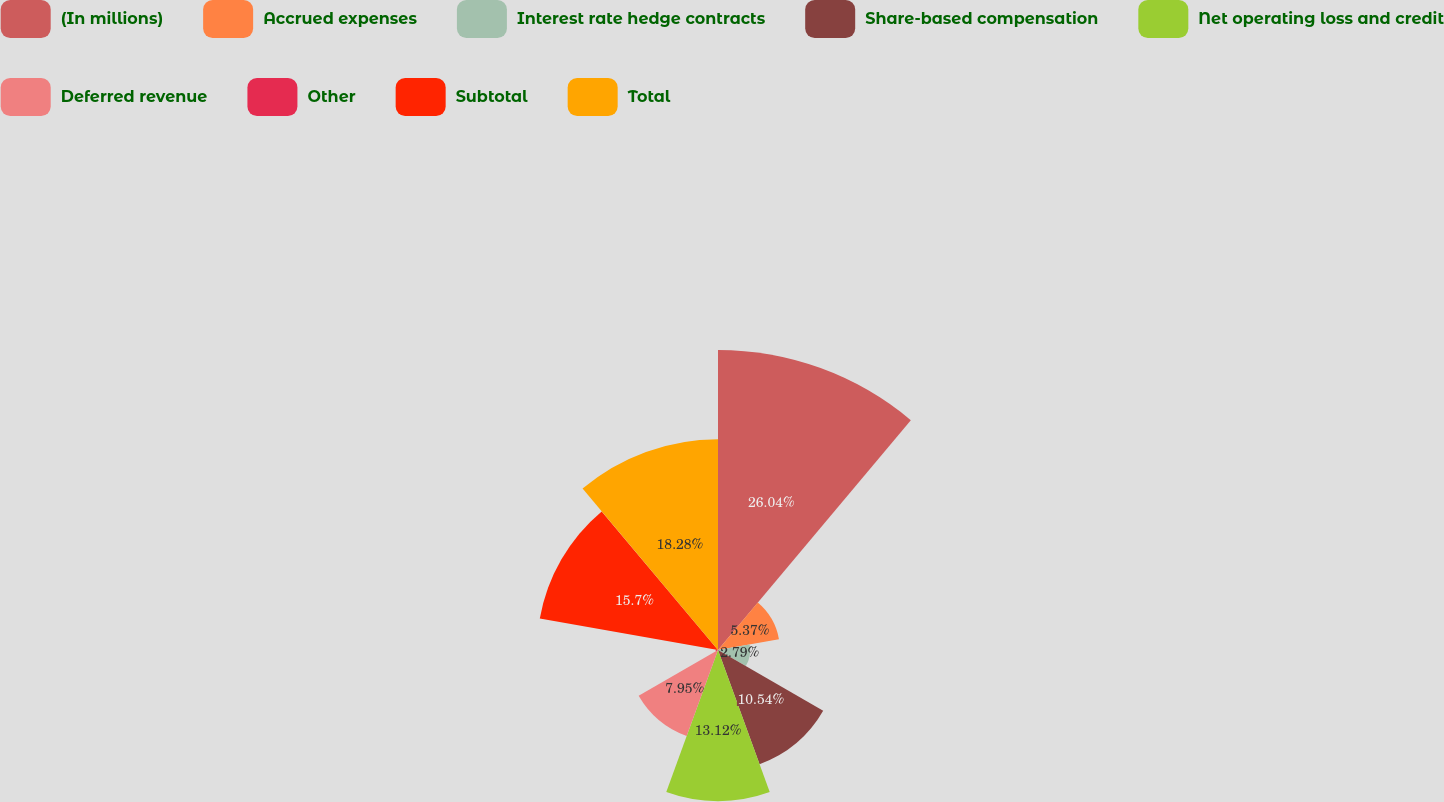Convert chart. <chart><loc_0><loc_0><loc_500><loc_500><pie_chart><fcel>(In millions)<fcel>Accrued expenses<fcel>Interest rate hedge contracts<fcel>Share-based compensation<fcel>Net operating loss and credit<fcel>Deferred revenue<fcel>Other<fcel>Subtotal<fcel>Total<nl><fcel>26.03%<fcel>5.37%<fcel>2.79%<fcel>10.54%<fcel>13.12%<fcel>7.95%<fcel>0.21%<fcel>15.7%<fcel>18.28%<nl></chart> 